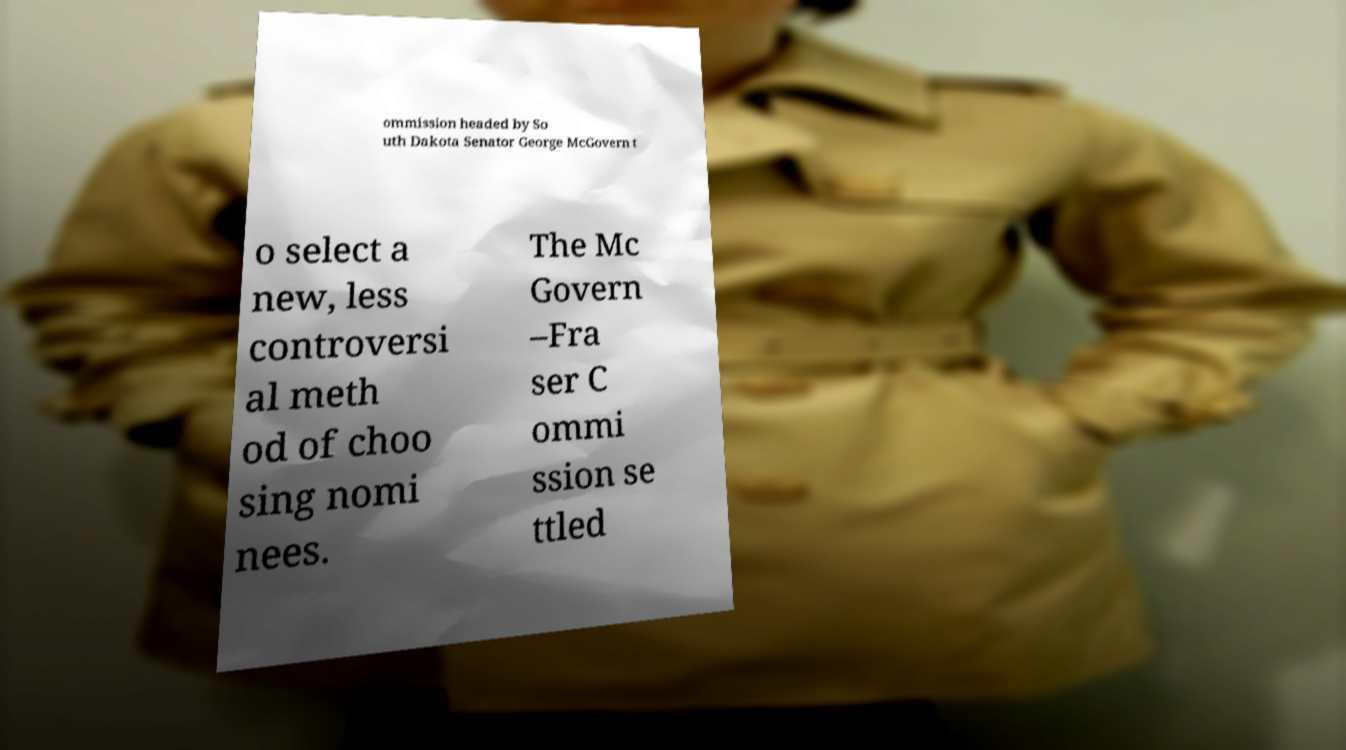For documentation purposes, I need the text within this image transcribed. Could you provide that? ommission headed by So uth Dakota Senator George McGovern t o select a new, less controversi al meth od of choo sing nomi nees. The Mc Govern –Fra ser C ommi ssion se ttled 